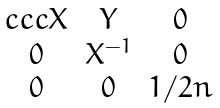Convert formula to latex. <formula><loc_0><loc_0><loc_500><loc_500>\begin{matrix} { c c c } X & Y & 0 \\ 0 & X ^ { - 1 } & 0 \\ 0 & 0 & 1 / 2 n \end{matrix}</formula> 